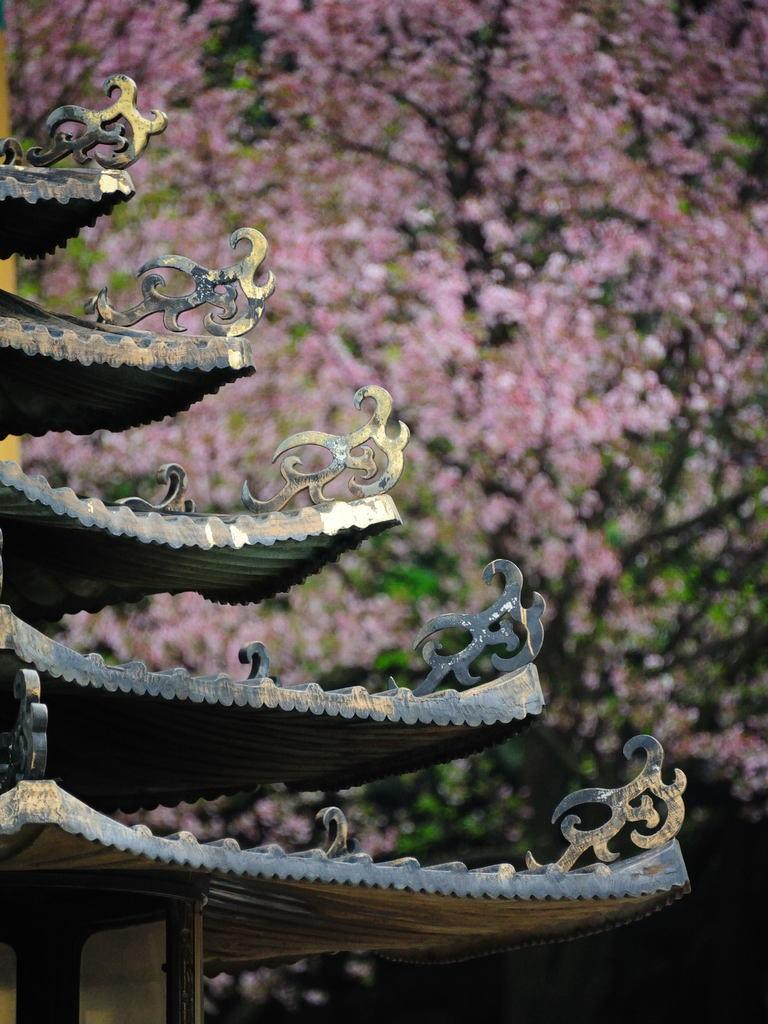What part of a house can be seen in the image? The roof of a house can be seen in the image. What type of artistic objects are present in the image? There are sculptures in the image. What can be seen in the distance in the image? There are many trees in the background of the image. How do the spiders move around on the roof in the image? There are no spiders present in the image, so their movement cannot be observed. 